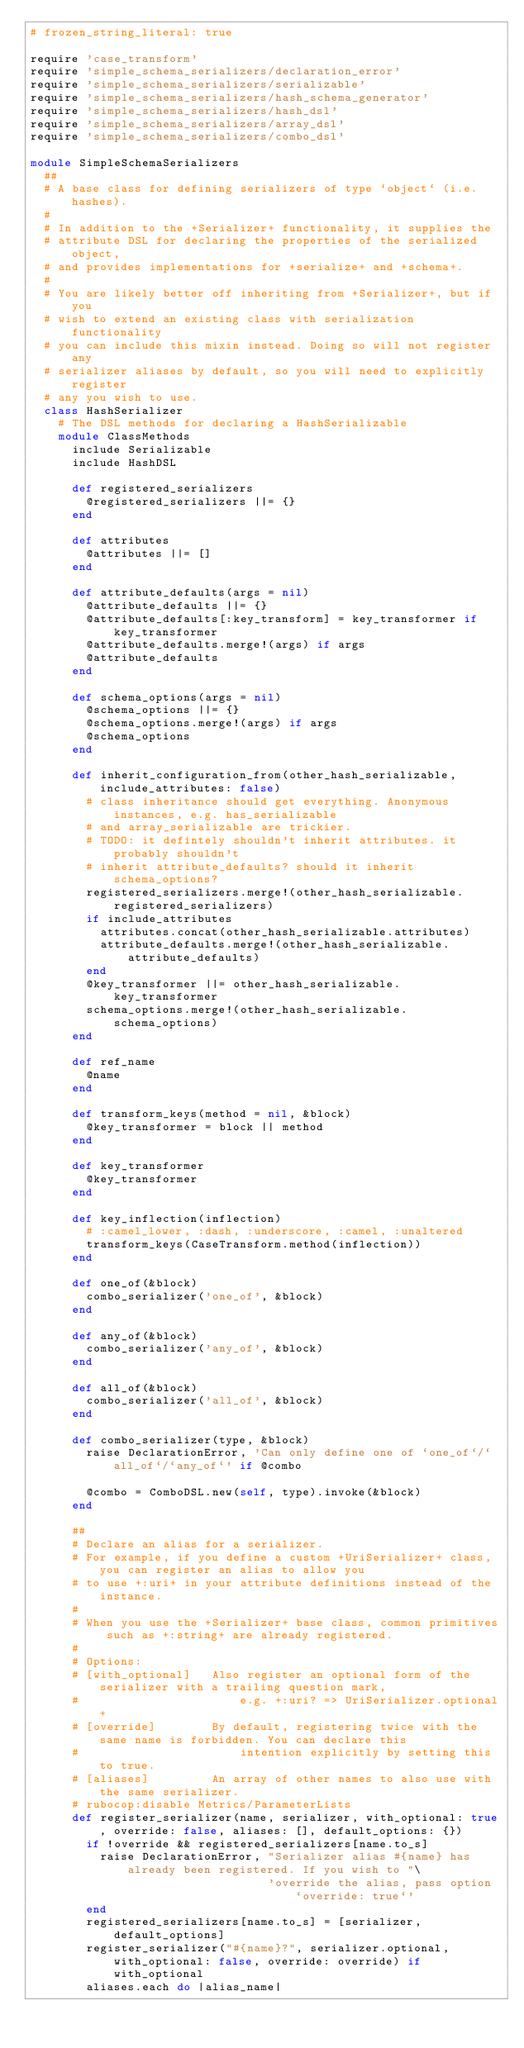<code> <loc_0><loc_0><loc_500><loc_500><_Ruby_># frozen_string_literal: true

require 'case_transform'
require 'simple_schema_serializers/declaration_error'
require 'simple_schema_serializers/serializable'
require 'simple_schema_serializers/hash_schema_generator'
require 'simple_schema_serializers/hash_dsl'
require 'simple_schema_serializers/array_dsl'
require 'simple_schema_serializers/combo_dsl'

module SimpleSchemaSerializers
  ##
  # A base class for defining serializers of type `object` (i.e. hashes).
  #
  # In addition to the +Serializer+ functionality, it supplies the
  # attribute DSL for declaring the properties of the serialized object,
  # and provides implementations for +serialize+ and +schema+.
  #
  # You are likely better off inheriting from +Serializer+, but if you
  # wish to extend an existing class with serialization functionality
  # you can include this mixin instead. Doing so will not register any
  # serializer aliases by default, so you will need to explicitly register
  # any you wish to use.
  class HashSerializer
    # The DSL methods for declaring a HashSerializable
    module ClassMethods
      include Serializable
      include HashDSL

      def registered_serializers
        @registered_serializers ||= {}
      end

      def attributes
        @attributes ||= []
      end

      def attribute_defaults(args = nil)
        @attribute_defaults ||= {}
        @attribute_defaults[:key_transform] = key_transformer if key_transformer
        @attribute_defaults.merge!(args) if args
        @attribute_defaults
      end

      def schema_options(args = nil)
        @schema_options ||= {}
        @schema_options.merge!(args) if args
        @schema_options
      end

      def inherit_configuration_from(other_hash_serializable, include_attributes: false)
        # class inheritance should get everything. Anonymous instances, e.g. has_serializable
        # and array_serializable are trickier.
        # TODO: it defintely shouldn't inherit attributes. it probably shouldn't
        # inherit attribute_defaults? should it inherit schema_options?
        registered_serializers.merge!(other_hash_serializable.registered_serializers)
        if include_attributes
          attributes.concat(other_hash_serializable.attributes)
          attribute_defaults.merge!(other_hash_serializable.attribute_defaults)
        end
        @key_transformer ||= other_hash_serializable.key_transformer
        schema_options.merge!(other_hash_serializable.schema_options)
      end

      def ref_name
        @name
      end

      def transform_keys(method = nil, &block)
        @key_transformer = block || method
      end

      def key_transformer
        @key_transformer
      end

      def key_inflection(inflection)
        # :camel_lower, :dash, :underscore, :camel, :unaltered
        transform_keys(CaseTransform.method(inflection))
      end

      def one_of(&block)
        combo_serializer('one_of', &block)
      end

      def any_of(&block)
        combo_serializer('any_of', &block)
      end

      def all_of(&block)
        combo_serializer('all_of', &block)
      end

      def combo_serializer(type, &block)
        raise DeclarationError, 'Can only define one of `one_of`/`all_of`/`any_of`' if @combo

        @combo = ComboDSL.new(self, type).invoke(&block)
      end

      ##
      # Declare an alias for a serializer.
      # For example, if you define a custom +UriSerializer+ class, you can register an alias to allow you
      # to use +:uri+ in your attribute definitions instead of the instance.
      #
      # When you use the +Serializer+ base class, common primitives such as +:string+ are already registered.
      #
      # Options:
      # [with_optional]   Also register an optional form of the serializer with a trailing question mark,
      #                       e.g. +:uri? => UriSerializer.optional+
      # [override]        By default, registering twice with the same name is forbidden. You can declare this
      #                       intention explicitly by setting this to true.
      # [aliases]         An array of other names to also use with the same serializer.
      # rubocop:disable Metrics/ParameterLists
      def register_serializer(name, serializer, with_optional: true, override: false, aliases: [], default_options: {})
        if !override && registered_serializers[name.to_s]
          raise DeclarationError, "Serializer alias #{name} has already been registered. If you wish to "\
                                  'override the alias, pass option `override: true`'
        end
        registered_serializers[name.to_s] = [serializer, default_options]
        register_serializer("#{name}?", serializer.optional, with_optional: false, override: override) if with_optional
        aliases.each do |alias_name|</code> 